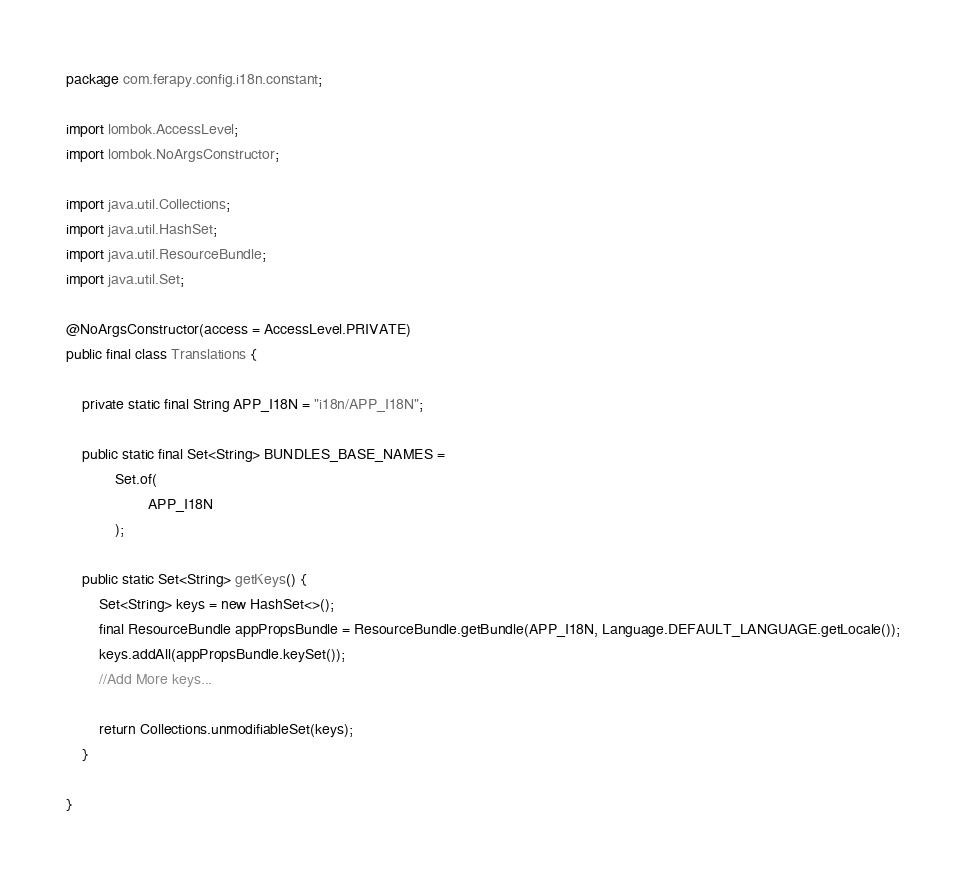Convert code to text. <code><loc_0><loc_0><loc_500><loc_500><_Java_>package com.ferapy.config.i18n.constant;

import lombok.AccessLevel;
import lombok.NoArgsConstructor;

import java.util.Collections;
import java.util.HashSet;
import java.util.ResourceBundle;
import java.util.Set;

@NoArgsConstructor(access = AccessLevel.PRIVATE)
public final class Translations {

    private static final String APP_I18N = "i18n/APP_I18N";

    public static final Set<String> BUNDLES_BASE_NAMES =
            Set.of(
                    APP_I18N
            );

    public static Set<String> getKeys() {
        Set<String> keys = new HashSet<>();
        final ResourceBundle appPropsBundle = ResourceBundle.getBundle(APP_I18N, Language.DEFAULT_LANGUAGE.getLocale());
        keys.addAll(appPropsBundle.keySet());
        //Add More keys...

        return Collections.unmodifiableSet(keys);
    }

}
</code> 